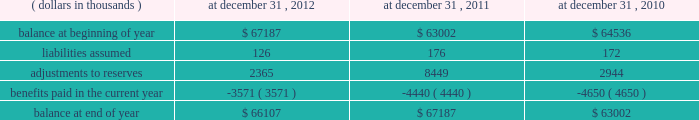At december 31 , 2012 , the gross reserves for a&e losses were comprised of $ 138449 thousand representing case reserves reported by ceding companies , $ 90637 thousand representing additional case reserves established by the company on assumed reinsurance claims , $ 36667 thousand representing case reserves established by the company on direct excess insurance claims , including mt .
Mckinley , and $ 177068 thousand representing ibnr reserves .
With respect to asbestos only , at december 31 , 2012 , the company had gross asbestos loss reserves of $ 422849 thousand , or 95.5% ( 95.5 % ) , of total a&e reserves , of which $ 339654 thousand was for assumed business and $ 83195 thousand was for direct business .
Future policy benefit reserve .
Activity in the reserve for future policy benefits is summarized for the periods indicated: .
Fair value the company 2019s fixed maturity and equity securities are primarily managed by third party investment asset managers .
The investment asset managers obtain prices from nationally recognized pricing services .
These services seek to utilize market data and observations in their evaluation process .
They use pricing applications that vary by asset class and incorporate available market information and when fixed maturity securities do not trade on a daily basis the services will apply available information through processes such as benchmark curves , benchmarking of like securities , sector groupings and matrix pricing .
In addition , they use model processes , such as the option adjusted spread model to develop prepayment and interest rate scenarios for securities that have prepayment features .
In limited instances where prices are not provided by pricing services or in rare instances when a manager may not agree with the pricing service , price quotes on a non-binding basis are obtained from investment brokers .
The investment asset managers do not make any changes to prices received from either the pricing services or the investment brokers .
In addition , the investment asset managers have procedures in place to review the reasonableness of the prices from the service providers and may request verification of the prices .
In addition , the company continually performs analytical reviews of price changes and tests the prices on a random basis to an independent pricing source .
No material variances were noted during these price validation procedures .
In limited situations , where financial markets are inactive or illiquid , the company may use its own assumptions about future cash flows and risk-adjusted discount rates to determine fair value .
The company made no such adjustments at december 31 , 2012 and 2011 .
The company internally manages a small public equity portfolio which had a fair value at december 31 , 2012 of $ 117602 thousand and all prices were obtained from publically published sources .
Equity securities in u.s .
Denominated currency are categorized as level 1 , quoted prices in active markets for identical assets , since the securities are actively traded on an exchange and prices are based on quoted prices from the exchange .
Equity securities traded on foreign exchanges are categorized as level 2 due to potential foreign exchange adjustments to fair or market value .
Fixed maturity securities are generally categorized as level 2 , significant other observable inputs , since a particular security may not have traded but the pricing services are able to use valuation models with observable market inputs such as interest rate yield curves and prices for similar fixed maturity securities in terms of issuer , maturity and seniority .
Valuations that are derived from techniques in which one or more of the significant inputs are unobservable ( including assumptions about risk ) are categorized as level 3 .
At december 31 , 2012 , what was the ratio of the case reserves reported by ceding to the additional case reserves established by the company? 
Computations: (138449 / 90637)
Answer: 1.52751. 